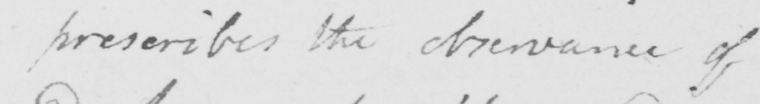What does this handwritten line say? prescribes the observance of 